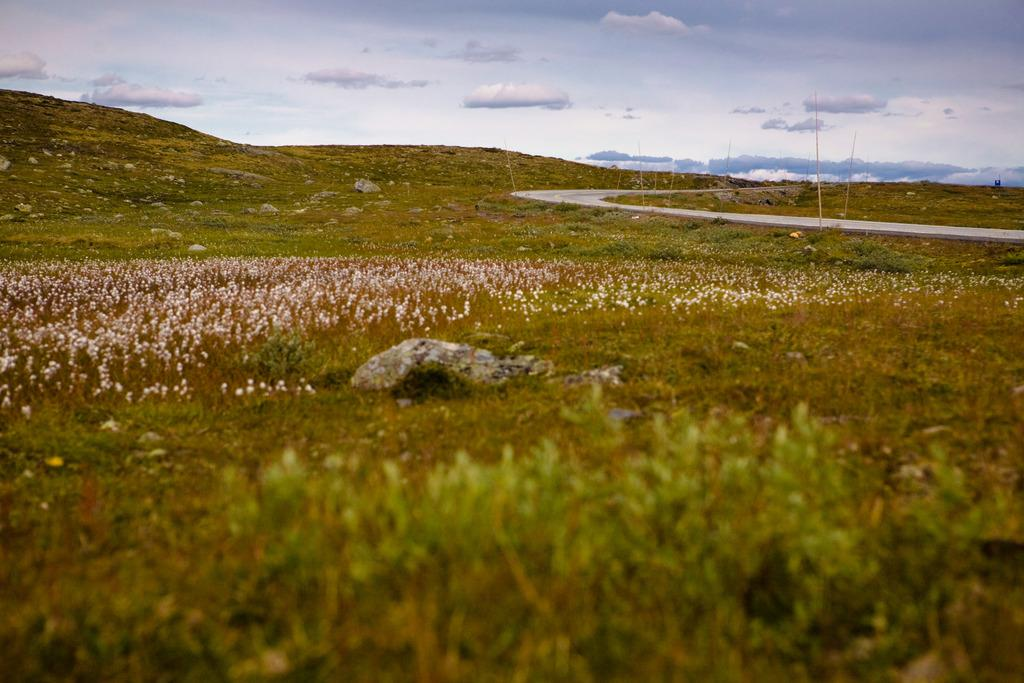What type of living organisms can be seen in the image? Plants can be seen in the image. What other objects are present in the image? There are rocks and poles on the ground in the image. What can be seen in the sky in the image? There are clouds in the sky in the image. What type of stocking is being used by the plants in the image? There is no stocking present in the image, as plants do not wear stockings. What activity are the rocks participating in within the image? The rocks are not participating in any activity, as they are inanimate objects. 